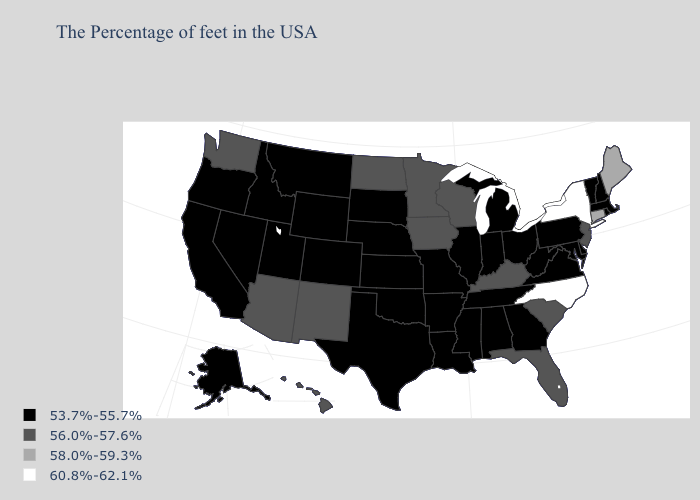What is the value of South Carolina?
Short answer required. 56.0%-57.6%. Name the states that have a value in the range 58.0%-59.3%?
Quick response, please. Maine, Connecticut. Name the states that have a value in the range 58.0%-59.3%?
Answer briefly. Maine, Connecticut. Name the states that have a value in the range 56.0%-57.6%?
Quick response, please. New Jersey, South Carolina, Florida, Kentucky, Wisconsin, Minnesota, Iowa, North Dakota, New Mexico, Arizona, Washington, Hawaii. What is the value of Wyoming?
Answer briefly. 53.7%-55.7%. Does Alabama have a lower value than Maine?
Keep it brief. Yes. What is the value of New Mexico?
Short answer required. 56.0%-57.6%. Does North Carolina have the highest value in the South?
Answer briefly. Yes. Among the states that border Vermont , which have the highest value?
Keep it brief. New York. What is the value of Oklahoma?
Write a very short answer. 53.7%-55.7%. What is the highest value in states that border Wyoming?
Concise answer only. 53.7%-55.7%. What is the lowest value in the USA?
Quick response, please. 53.7%-55.7%. Name the states that have a value in the range 60.8%-62.1%?
Keep it brief. New York, North Carolina. Does Oregon have the lowest value in the USA?
Give a very brief answer. Yes. Which states hav the highest value in the MidWest?
Give a very brief answer. Wisconsin, Minnesota, Iowa, North Dakota. 